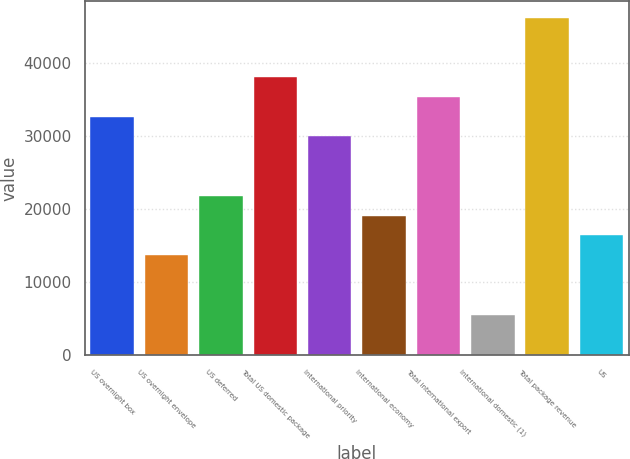<chart> <loc_0><loc_0><loc_500><loc_500><bar_chart><fcel>US overnight box<fcel>US overnight envelope<fcel>US deferred<fcel>Total US domestic package<fcel>International priority<fcel>International economy<fcel>Total international export<fcel>International domestic (1)<fcel>Total package revenue<fcel>US<nl><fcel>32650.8<fcel>13709.5<fcel>21827.2<fcel>38062.6<fcel>29944.9<fcel>19121.3<fcel>35356.7<fcel>5591.8<fcel>46180.3<fcel>16415.4<nl></chart> 